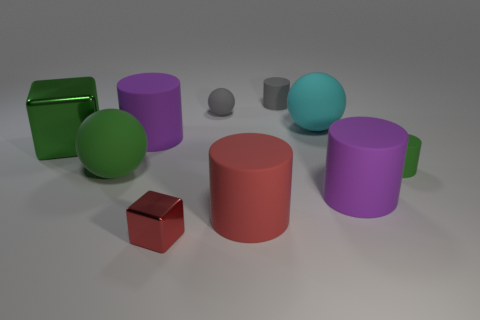What material is the red block on the left side of the large matte ball behind the large cylinder behind the green matte cylinder?
Provide a short and direct response. Metal. Is the number of large red matte cylinders on the right side of the large red rubber thing less than the number of large green blocks?
Offer a terse response. Yes. What material is the green thing that is the same size as the green cube?
Your answer should be very brief. Rubber. What size is the rubber cylinder that is left of the small gray cylinder and to the right of the red block?
Give a very brief answer. Large. What size is the green matte object that is the same shape as the large red object?
Make the answer very short. Small. What number of objects are small gray spheres or objects to the left of the tiny red metal object?
Make the answer very short. 4. What is the shape of the large cyan thing?
Your answer should be compact. Sphere. What shape is the big purple thing that is in front of the purple cylinder behind the large green metal object?
Give a very brief answer. Cylinder. The other object that is made of the same material as the small red thing is what color?
Ensure brevity in your answer.  Green. Do the tiny object on the right side of the small gray cylinder and the sphere in front of the big green block have the same color?
Ensure brevity in your answer.  Yes. 